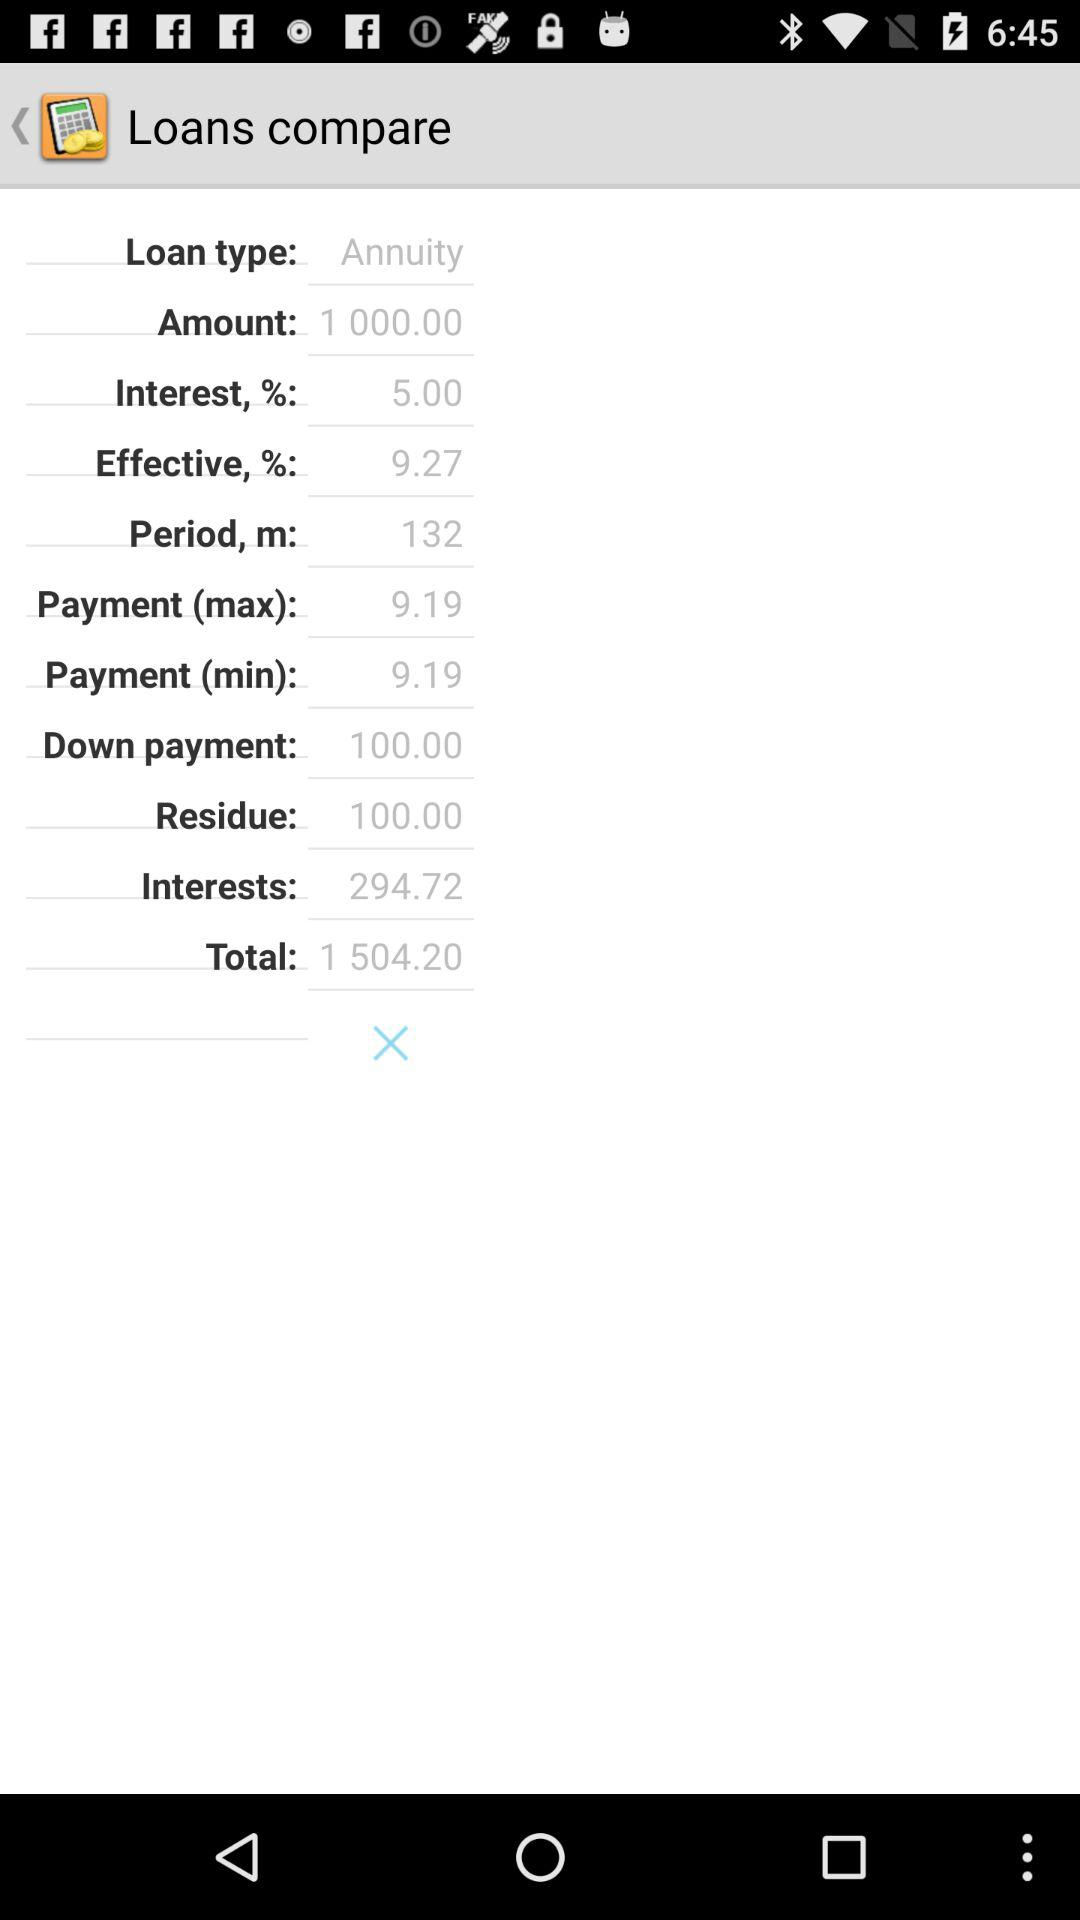What is the amount? The amount is 1000.00. 